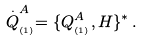Convert formula to latex. <formula><loc_0><loc_0><loc_500><loc_500>\stackrel { . } { Q } _ { _ { ( 1 ) } } ^ { A } = \{ Q _ { _ { ( 1 ) } } ^ { A } , H \} ^ { * } \, .</formula> 